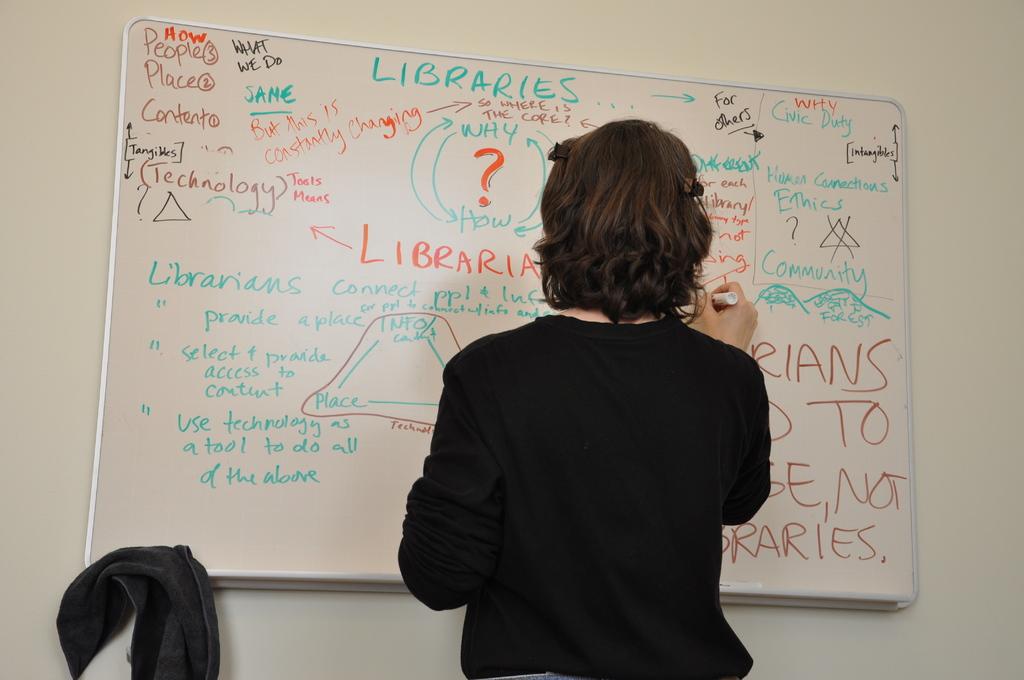Is the topic of this meeting about different libraries?
Provide a succinct answer. Yes. This lady appears to be teaching what subject?
Provide a short and direct response. Libraries. 